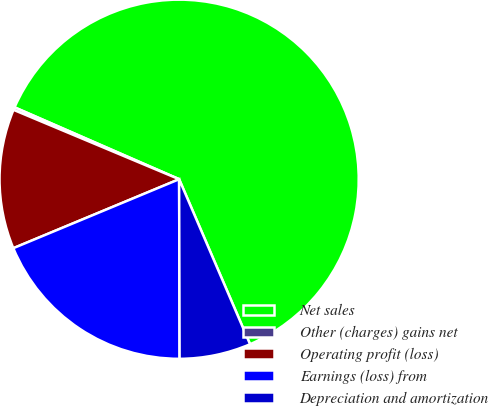Convert chart to OTSL. <chart><loc_0><loc_0><loc_500><loc_500><pie_chart><fcel>Net sales<fcel>Other (charges) gains net<fcel>Operating profit (loss)<fcel>Earnings (loss) from<fcel>Depreciation and amortization<nl><fcel>61.99%<fcel>0.24%<fcel>12.59%<fcel>18.77%<fcel>6.42%<nl></chart> 